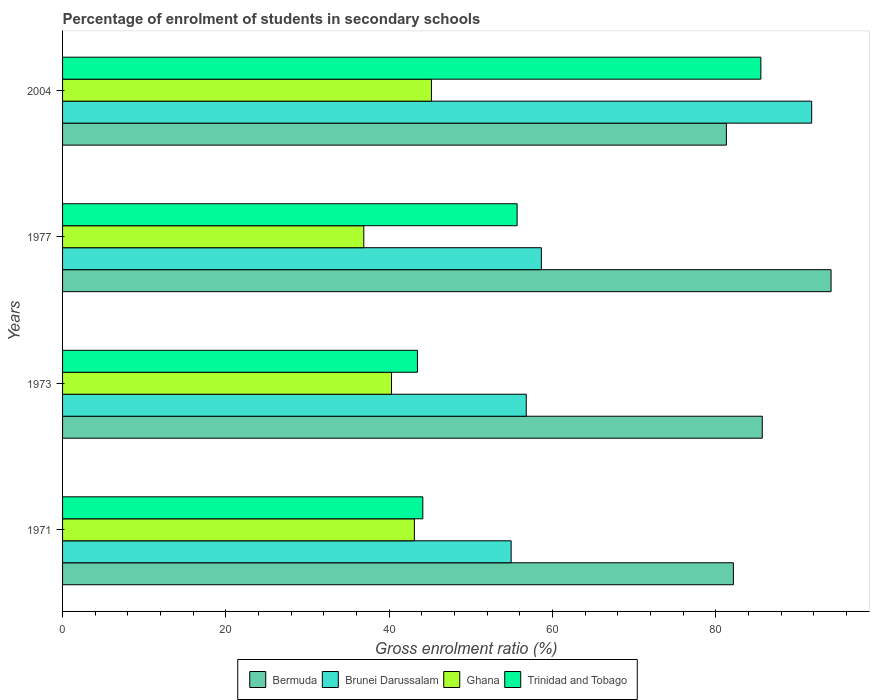What is the label of the 3rd group of bars from the top?
Your answer should be very brief. 1973. In how many cases, is the number of bars for a given year not equal to the number of legend labels?
Your response must be concise. 0. What is the percentage of students enrolled in secondary schools in Ghana in 2004?
Keep it short and to the point. 45.17. Across all years, what is the maximum percentage of students enrolled in secondary schools in Brunei Darussalam?
Your answer should be very brief. 91.74. Across all years, what is the minimum percentage of students enrolled in secondary schools in Brunei Darussalam?
Keep it short and to the point. 54.94. What is the total percentage of students enrolled in secondary schools in Brunei Darussalam in the graph?
Offer a terse response. 262.11. What is the difference between the percentage of students enrolled in secondary schools in Ghana in 1973 and that in 1977?
Keep it short and to the point. 3.39. What is the difference between the percentage of students enrolled in secondary schools in Trinidad and Tobago in 1971 and the percentage of students enrolled in secondary schools in Brunei Darussalam in 2004?
Give a very brief answer. -47.62. What is the average percentage of students enrolled in secondary schools in Bermuda per year?
Provide a succinct answer. 85.82. In the year 1977, what is the difference between the percentage of students enrolled in secondary schools in Trinidad and Tobago and percentage of students enrolled in secondary schools in Ghana?
Your answer should be very brief. 18.78. In how many years, is the percentage of students enrolled in secondary schools in Brunei Darussalam greater than 16 %?
Make the answer very short. 4. What is the ratio of the percentage of students enrolled in secondary schools in Brunei Darussalam in 1971 to that in 2004?
Give a very brief answer. 0.6. Is the difference between the percentage of students enrolled in secondary schools in Trinidad and Tobago in 1973 and 1977 greater than the difference between the percentage of students enrolled in secondary schools in Ghana in 1973 and 1977?
Offer a very short reply. No. What is the difference between the highest and the second highest percentage of students enrolled in secondary schools in Ghana?
Provide a short and direct response. 2.09. What is the difference between the highest and the lowest percentage of students enrolled in secondary schools in Bermuda?
Ensure brevity in your answer.  12.82. In how many years, is the percentage of students enrolled in secondary schools in Brunei Darussalam greater than the average percentage of students enrolled in secondary schools in Brunei Darussalam taken over all years?
Provide a short and direct response. 1. What does the 3rd bar from the top in 1977 represents?
Offer a terse response. Brunei Darussalam. Are all the bars in the graph horizontal?
Offer a very short reply. Yes. How many years are there in the graph?
Make the answer very short. 4. What is the difference between two consecutive major ticks on the X-axis?
Your answer should be compact. 20. Are the values on the major ticks of X-axis written in scientific E-notation?
Ensure brevity in your answer.  No. How many legend labels are there?
Offer a very short reply. 4. What is the title of the graph?
Keep it short and to the point. Percentage of enrolment of students in secondary schools. What is the Gross enrolment ratio (%) in Bermuda in 1971?
Provide a succinct answer. 82.16. What is the Gross enrolment ratio (%) of Brunei Darussalam in 1971?
Offer a terse response. 54.94. What is the Gross enrolment ratio (%) in Ghana in 1971?
Provide a succinct answer. 43.09. What is the Gross enrolment ratio (%) in Trinidad and Tobago in 1971?
Provide a short and direct response. 44.12. What is the Gross enrolment ratio (%) in Bermuda in 1973?
Offer a terse response. 85.69. What is the Gross enrolment ratio (%) of Brunei Darussalam in 1973?
Your answer should be compact. 56.79. What is the Gross enrolment ratio (%) in Ghana in 1973?
Offer a terse response. 40.28. What is the Gross enrolment ratio (%) in Trinidad and Tobago in 1973?
Make the answer very short. 43.46. What is the Gross enrolment ratio (%) in Bermuda in 1977?
Ensure brevity in your answer.  94.12. What is the Gross enrolment ratio (%) of Brunei Darussalam in 1977?
Keep it short and to the point. 58.64. What is the Gross enrolment ratio (%) of Ghana in 1977?
Offer a terse response. 36.89. What is the Gross enrolment ratio (%) in Trinidad and Tobago in 1977?
Provide a succinct answer. 55.67. What is the Gross enrolment ratio (%) in Bermuda in 2004?
Provide a succinct answer. 81.3. What is the Gross enrolment ratio (%) of Brunei Darussalam in 2004?
Make the answer very short. 91.74. What is the Gross enrolment ratio (%) in Ghana in 2004?
Provide a succinct answer. 45.17. What is the Gross enrolment ratio (%) of Trinidad and Tobago in 2004?
Offer a terse response. 85.52. Across all years, what is the maximum Gross enrolment ratio (%) of Bermuda?
Your answer should be compact. 94.12. Across all years, what is the maximum Gross enrolment ratio (%) of Brunei Darussalam?
Provide a short and direct response. 91.74. Across all years, what is the maximum Gross enrolment ratio (%) in Ghana?
Offer a very short reply. 45.17. Across all years, what is the maximum Gross enrolment ratio (%) in Trinidad and Tobago?
Provide a succinct answer. 85.52. Across all years, what is the minimum Gross enrolment ratio (%) in Bermuda?
Your response must be concise. 81.3. Across all years, what is the minimum Gross enrolment ratio (%) in Brunei Darussalam?
Offer a very short reply. 54.94. Across all years, what is the minimum Gross enrolment ratio (%) in Ghana?
Offer a terse response. 36.89. Across all years, what is the minimum Gross enrolment ratio (%) in Trinidad and Tobago?
Provide a short and direct response. 43.46. What is the total Gross enrolment ratio (%) of Bermuda in the graph?
Your response must be concise. 343.26. What is the total Gross enrolment ratio (%) in Brunei Darussalam in the graph?
Offer a terse response. 262.11. What is the total Gross enrolment ratio (%) of Ghana in the graph?
Provide a succinct answer. 165.43. What is the total Gross enrolment ratio (%) of Trinidad and Tobago in the graph?
Provide a short and direct response. 228.77. What is the difference between the Gross enrolment ratio (%) of Bermuda in 1971 and that in 1973?
Your answer should be very brief. -3.54. What is the difference between the Gross enrolment ratio (%) in Brunei Darussalam in 1971 and that in 1973?
Your answer should be very brief. -1.85. What is the difference between the Gross enrolment ratio (%) of Ghana in 1971 and that in 1973?
Your response must be concise. 2.8. What is the difference between the Gross enrolment ratio (%) of Trinidad and Tobago in 1971 and that in 1973?
Offer a very short reply. 0.66. What is the difference between the Gross enrolment ratio (%) in Bermuda in 1971 and that in 1977?
Give a very brief answer. -11.96. What is the difference between the Gross enrolment ratio (%) in Brunei Darussalam in 1971 and that in 1977?
Your answer should be compact. -3.7. What is the difference between the Gross enrolment ratio (%) of Ghana in 1971 and that in 1977?
Keep it short and to the point. 6.19. What is the difference between the Gross enrolment ratio (%) of Trinidad and Tobago in 1971 and that in 1977?
Ensure brevity in your answer.  -11.55. What is the difference between the Gross enrolment ratio (%) in Bermuda in 1971 and that in 2004?
Give a very brief answer. 0.86. What is the difference between the Gross enrolment ratio (%) of Brunei Darussalam in 1971 and that in 2004?
Offer a very short reply. -36.81. What is the difference between the Gross enrolment ratio (%) of Ghana in 1971 and that in 2004?
Provide a short and direct response. -2.09. What is the difference between the Gross enrolment ratio (%) in Trinidad and Tobago in 1971 and that in 2004?
Give a very brief answer. -41.4. What is the difference between the Gross enrolment ratio (%) in Bermuda in 1973 and that in 1977?
Your answer should be very brief. -8.43. What is the difference between the Gross enrolment ratio (%) of Brunei Darussalam in 1973 and that in 1977?
Offer a terse response. -1.85. What is the difference between the Gross enrolment ratio (%) in Ghana in 1973 and that in 1977?
Ensure brevity in your answer.  3.39. What is the difference between the Gross enrolment ratio (%) of Trinidad and Tobago in 1973 and that in 1977?
Offer a terse response. -12.21. What is the difference between the Gross enrolment ratio (%) of Bermuda in 1973 and that in 2004?
Ensure brevity in your answer.  4.4. What is the difference between the Gross enrolment ratio (%) of Brunei Darussalam in 1973 and that in 2004?
Keep it short and to the point. -34.96. What is the difference between the Gross enrolment ratio (%) of Ghana in 1973 and that in 2004?
Offer a terse response. -4.89. What is the difference between the Gross enrolment ratio (%) of Trinidad and Tobago in 1973 and that in 2004?
Your response must be concise. -42.06. What is the difference between the Gross enrolment ratio (%) in Bermuda in 1977 and that in 2004?
Offer a terse response. 12.82. What is the difference between the Gross enrolment ratio (%) of Brunei Darussalam in 1977 and that in 2004?
Make the answer very short. -33.1. What is the difference between the Gross enrolment ratio (%) in Ghana in 1977 and that in 2004?
Ensure brevity in your answer.  -8.28. What is the difference between the Gross enrolment ratio (%) in Trinidad and Tobago in 1977 and that in 2004?
Offer a very short reply. -29.85. What is the difference between the Gross enrolment ratio (%) in Bermuda in 1971 and the Gross enrolment ratio (%) in Brunei Darussalam in 1973?
Make the answer very short. 25.37. What is the difference between the Gross enrolment ratio (%) of Bermuda in 1971 and the Gross enrolment ratio (%) of Ghana in 1973?
Offer a terse response. 41.87. What is the difference between the Gross enrolment ratio (%) of Bermuda in 1971 and the Gross enrolment ratio (%) of Trinidad and Tobago in 1973?
Keep it short and to the point. 38.69. What is the difference between the Gross enrolment ratio (%) of Brunei Darussalam in 1971 and the Gross enrolment ratio (%) of Ghana in 1973?
Make the answer very short. 14.65. What is the difference between the Gross enrolment ratio (%) in Brunei Darussalam in 1971 and the Gross enrolment ratio (%) in Trinidad and Tobago in 1973?
Make the answer very short. 11.47. What is the difference between the Gross enrolment ratio (%) in Ghana in 1971 and the Gross enrolment ratio (%) in Trinidad and Tobago in 1973?
Provide a short and direct response. -0.38. What is the difference between the Gross enrolment ratio (%) in Bermuda in 1971 and the Gross enrolment ratio (%) in Brunei Darussalam in 1977?
Your answer should be very brief. 23.52. What is the difference between the Gross enrolment ratio (%) of Bermuda in 1971 and the Gross enrolment ratio (%) of Ghana in 1977?
Your answer should be compact. 45.26. What is the difference between the Gross enrolment ratio (%) of Bermuda in 1971 and the Gross enrolment ratio (%) of Trinidad and Tobago in 1977?
Ensure brevity in your answer.  26.49. What is the difference between the Gross enrolment ratio (%) of Brunei Darussalam in 1971 and the Gross enrolment ratio (%) of Ghana in 1977?
Provide a succinct answer. 18.04. What is the difference between the Gross enrolment ratio (%) in Brunei Darussalam in 1971 and the Gross enrolment ratio (%) in Trinidad and Tobago in 1977?
Make the answer very short. -0.73. What is the difference between the Gross enrolment ratio (%) in Ghana in 1971 and the Gross enrolment ratio (%) in Trinidad and Tobago in 1977?
Offer a very short reply. -12.58. What is the difference between the Gross enrolment ratio (%) of Bermuda in 1971 and the Gross enrolment ratio (%) of Brunei Darussalam in 2004?
Your answer should be very brief. -9.59. What is the difference between the Gross enrolment ratio (%) in Bermuda in 1971 and the Gross enrolment ratio (%) in Ghana in 2004?
Provide a short and direct response. 36.98. What is the difference between the Gross enrolment ratio (%) of Bermuda in 1971 and the Gross enrolment ratio (%) of Trinidad and Tobago in 2004?
Ensure brevity in your answer.  -3.37. What is the difference between the Gross enrolment ratio (%) in Brunei Darussalam in 1971 and the Gross enrolment ratio (%) in Ghana in 2004?
Your response must be concise. 9.76. What is the difference between the Gross enrolment ratio (%) in Brunei Darussalam in 1971 and the Gross enrolment ratio (%) in Trinidad and Tobago in 2004?
Give a very brief answer. -30.59. What is the difference between the Gross enrolment ratio (%) of Ghana in 1971 and the Gross enrolment ratio (%) of Trinidad and Tobago in 2004?
Offer a very short reply. -42.44. What is the difference between the Gross enrolment ratio (%) in Bermuda in 1973 and the Gross enrolment ratio (%) in Brunei Darussalam in 1977?
Make the answer very short. 27.05. What is the difference between the Gross enrolment ratio (%) of Bermuda in 1973 and the Gross enrolment ratio (%) of Ghana in 1977?
Provide a short and direct response. 48.8. What is the difference between the Gross enrolment ratio (%) of Bermuda in 1973 and the Gross enrolment ratio (%) of Trinidad and Tobago in 1977?
Your answer should be very brief. 30.03. What is the difference between the Gross enrolment ratio (%) of Brunei Darussalam in 1973 and the Gross enrolment ratio (%) of Ghana in 1977?
Provide a succinct answer. 19.89. What is the difference between the Gross enrolment ratio (%) in Brunei Darussalam in 1973 and the Gross enrolment ratio (%) in Trinidad and Tobago in 1977?
Offer a very short reply. 1.12. What is the difference between the Gross enrolment ratio (%) of Ghana in 1973 and the Gross enrolment ratio (%) of Trinidad and Tobago in 1977?
Make the answer very short. -15.39. What is the difference between the Gross enrolment ratio (%) in Bermuda in 1973 and the Gross enrolment ratio (%) in Brunei Darussalam in 2004?
Your answer should be compact. -6.05. What is the difference between the Gross enrolment ratio (%) of Bermuda in 1973 and the Gross enrolment ratio (%) of Ghana in 2004?
Your answer should be compact. 40.52. What is the difference between the Gross enrolment ratio (%) of Bermuda in 1973 and the Gross enrolment ratio (%) of Trinidad and Tobago in 2004?
Keep it short and to the point. 0.17. What is the difference between the Gross enrolment ratio (%) in Brunei Darussalam in 1973 and the Gross enrolment ratio (%) in Ghana in 2004?
Your response must be concise. 11.61. What is the difference between the Gross enrolment ratio (%) in Brunei Darussalam in 1973 and the Gross enrolment ratio (%) in Trinidad and Tobago in 2004?
Make the answer very short. -28.74. What is the difference between the Gross enrolment ratio (%) of Ghana in 1973 and the Gross enrolment ratio (%) of Trinidad and Tobago in 2004?
Give a very brief answer. -45.24. What is the difference between the Gross enrolment ratio (%) of Bermuda in 1977 and the Gross enrolment ratio (%) of Brunei Darussalam in 2004?
Your response must be concise. 2.38. What is the difference between the Gross enrolment ratio (%) of Bermuda in 1977 and the Gross enrolment ratio (%) of Ghana in 2004?
Your answer should be compact. 48.94. What is the difference between the Gross enrolment ratio (%) in Bermuda in 1977 and the Gross enrolment ratio (%) in Trinidad and Tobago in 2004?
Make the answer very short. 8.6. What is the difference between the Gross enrolment ratio (%) of Brunei Darussalam in 1977 and the Gross enrolment ratio (%) of Ghana in 2004?
Your answer should be very brief. 13.47. What is the difference between the Gross enrolment ratio (%) in Brunei Darussalam in 1977 and the Gross enrolment ratio (%) in Trinidad and Tobago in 2004?
Make the answer very short. -26.88. What is the difference between the Gross enrolment ratio (%) in Ghana in 1977 and the Gross enrolment ratio (%) in Trinidad and Tobago in 2004?
Offer a terse response. -48.63. What is the average Gross enrolment ratio (%) in Bermuda per year?
Your answer should be compact. 85.82. What is the average Gross enrolment ratio (%) in Brunei Darussalam per year?
Offer a very short reply. 65.53. What is the average Gross enrolment ratio (%) of Ghana per year?
Your response must be concise. 41.36. What is the average Gross enrolment ratio (%) in Trinidad and Tobago per year?
Provide a succinct answer. 57.19. In the year 1971, what is the difference between the Gross enrolment ratio (%) of Bermuda and Gross enrolment ratio (%) of Brunei Darussalam?
Offer a very short reply. 27.22. In the year 1971, what is the difference between the Gross enrolment ratio (%) in Bermuda and Gross enrolment ratio (%) in Ghana?
Offer a very short reply. 39.07. In the year 1971, what is the difference between the Gross enrolment ratio (%) in Bermuda and Gross enrolment ratio (%) in Trinidad and Tobago?
Provide a succinct answer. 38.04. In the year 1971, what is the difference between the Gross enrolment ratio (%) of Brunei Darussalam and Gross enrolment ratio (%) of Ghana?
Provide a short and direct response. 11.85. In the year 1971, what is the difference between the Gross enrolment ratio (%) in Brunei Darussalam and Gross enrolment ratio (%) in Trinidad and Tobago?
Provide a succinct answer. 10.82. In the year 1971, what is the difference between the Gross enrolment ratio (%) of Ghana and Gross enrolment ratio (%) of Trinidad and Tobago?
Offer a very short reply. -1.03. In the year 1973, what is the difference between the Gross enrolment ratio (%) in Bermuda and Gross enrolment ratio (%) in Brunei Darussalam?
Ensure brevity in your answer.  28.91. In the year 1973, what is the difference between the Gross enrolment ratio (%) in Bermuda and Gross enrolment ratio (%) in Ghana?
Provide a succinct answer. 45.41. In the year 1973, what is the difference between the Gross enrolment ratio (%) of Bermuda and Gross enrolment ratio (%) of Trinidad and Tobago?
Keep it short and to the point. 42.23. In the year 1973, what is the difference between the Gross enrolment ratio (%) of Brunei Darussalam and Gross enrolment ratio (%) of Ghana?
Make the answer very short. 16.5. In the year 1973, what is the difference between the Gross enrolment ratio (%) in Brunei Darussalam and Gross enrolment ratio (%) in Trinidad and Tobago?
Give a very brief answer. 13.32. In the year 1973, what is the difference between the Gross enrolment ratio (%) of Ghana and Gross enrolment ratio (%) of Trinidad and Tobago?
Provide a short and direct response. -3.18. In the year 1977, what is the difference between the Gross enrolment ratio (%) of Bermuda and Gross enrolment ratio (%) of Brunei Darussalam?
Provide a succinct answer. 35.48. In the year 1977, what is the difference between the Gross enrolment ratio (%) in Bermuda and Gross enrolment ratio (%) in Ghana?
Your response must be concise. 57.23. In the year 1977, what is the difference between the Gross enrolment ratio (%) of Bermuda and Gross enrolment ratio (%) of Trinidad and Tobago?
Your response must be concise. 38.45. In the year 1977, what is the difference between the Gross enrolment ratio (%) in Brunei Darussalam and Gross enrolment ratio (%) in Ghana?
Offer a very short reply. 21.75. In the year 1977, what is the difference between the Gross enrolment ratio (%) in Brunei Darussalam and Gross enrolment ratio (%) in Trinidad and Tobago?
Offer a very short reply. 2.97. In the year 1977, what is the difference between the Gross enrolment ratio (%) in Ghana and Gross enrolment ratio (%) in Trinidad and Tobago?
Ensure brevity in your answer.  -18.78. In the year 2004, what is the difference between the Gross enrolment ratio (%) of Bermuda and Gross enrolment ratio (%) of Brunei Darussalam?
Keep it short and to the point. -10.45. In the year 2004, what is the difference between the Gross enrolment ratio (%) of Bermuda and Gross enrolment ratio (%) of Ghana?
Your answer should be very brief. 36.12. In the year 2004, what is the difference between the Gross enrolment ratio (%) in Bermuda and Gross enrolment ratio (%) in Trinidad and Tobago?
Make the answer very short. -4.23. In the year 2004, what is the difference between the Gross enrolment ratio (%) in Brunei Darussalam and Gross enrolment ratio (%) in Ghana?
Provide a short and direct response. 46.57. In the year 2004, what is the difference between the Gross enrolment ratio (%) in Brunei Darussalam and Gross enrolment ratio (%) in Trinidad and Tobago?
Give a very brief answer. 6.22. In the year 2004, what is the difference between the Gross enrolment ratio (%) in Ghana and Gross enrolment ratio (%) in Trinidad and Tobago?
Offer a terse response. -40.35. What is the ratio of the Gross enrolment ratio (%) of Bermuda in 1971 to that in 1973?
Offer a very short reply. 0.96. What is the ratio of the Gross enrolment ratio (%) in Brunei Darussalam in 1971 to that in 1973?
Ensure brevity in your answer.  0.97. What is the ratio of the Gross enrolment ratio (%) of Ghana in 1971 to that in 1973?
Offer a terse response. 1.07. What is the ratio of the Gross enrolment ratio (%) in Trinidad and Tobago in 1971 to that in 1973?
Your response must be concise. 1.02. What is the ratio of the Gross enrolment ratio (%) of Bermuda in 1971 to that in 1977?
Offer a terse response. 0.87. What is the ratio of the Gross enrolment ratio (%) in Brunei Darussalam in 1971 to that in 1977?
Give a very brief answer. 0.94. What is the ratio of the Gross enrolment ratio (%) of Ghana in 1971 to that in 1977?
Your answer should be compact. 1.17. What is the ratio of the Gross enrolment ratio (%) of Trinidad and Tobago in 1971 to that in 1977?
Offer a terse response. 0.79. What is the ratio of the Gross enrolment ratio (%) in Bermuda in 1971 to that in 2004?
Give a very brief answer. 1.01. What is the ratio of the Gross enrolment ratio (%) in Brunei Darussalam in 1971 to that in 2004?
Offer a very short reply. 0.6. What is the ratio of the Gross enrolment ratio (%) of Ghana in 1971 to that in 2004?
Make the answer very short. 0.95. What is the ratio of the Gross enrolment ratio (%) in Trinidad and Tobago in 1971 to that in 2004?
Make the answer very short. 0.52. What is the ratio of the Gross enrolment ratio (%) in Bermuda in 1973 to that in 1977?
Provide a short and direct response. 0.91. What is the ratio of the Gross enrolment ratio (%) of Brunei Darussalam in 1973 to that in 1977?
Make the answer very short. 0.97. What is the ratio of the Gross enrolment ratio (%) of Ghana in 1973 to that in 1977?
Give a very brief answer. 1.09. What is the ratio of the Gross enrolment ratio (%) of Trinidad and Tobago in 1973 to that in 1977?
Ensure brevity in your answer.  0.78. What is the ratio of the Gross enrolment ratio (%) in Bermuda in 1973 to that in 2004?
Offer a very short reply. 1.05. What is the ratio of the Gross enrolment ratio (%) of Brunei Darussalam in 1973 to that in 2004?
Keep it short and to the point. 0.62. What is the ratio of the Gross enrolment ratio (%) in Ghana in 1973 to that in 2004?
Your answer should be compact. 0.89. What is the ratio of the Gross enrolment ratio (%) in Trinidad and Tobago in 1973 to that in 2004?
Ensure brevity in your answer.  0.51. What is the ratio of the Gross enrolment ratio (%) of Bermuda in 1977 to that in 2004?
Provide a short and direct response. 1.16. What is the ratio of the Gross enrolment ratio (%) in Brunei Darussalam in 1977 to that in 2004?
Ensure brevity in your answer.  0.64. What is the ratio of the Gross enrolment ratio (%) in Ghana in 1977 to that in 2004?
Provide a short and direct response. 0.82. What is the ratio of the Gross enrolment ratio (%) of Trinidad and Tobago in 1977 to that in 2004?
Your answer should be compact. 0.65. What is the difference between the highest and the second highest Gross enrolment ratio (%) of Bermuda?
Give a very brief answer. 8.43. What is the difference between the highest and the second highest Gross enrolment ratio (%) of Brunei Darussalam?
Provide a short and direct response. 33.1. What is the difference between the highest and the second highest Gross enrolment ratio (%) in Ghana?
Give a very brief answer. 2.09. What is the difference between the highest and the second highest Gross enrolment ratio (%) of Trinidad and Tobago?
Keep it short and to the point. 29.85. What is the difference between the highest and the lowest Gross enrolment ratio (%) of Bermuda?
Your response must be concise. 12.82. What is the difference between the highest and the lowest Gross enrolment ratio (%) in Brunei Darussalam?
Make the answer very short. 36.81. What is the difference between the highest and the lowest Gross enrolment ratio (%) of Ghana?
Provide a short and direct response. 8.28. What is the difference between the highest and the lowest Gross enrolment ratio (%) in Trinidad and Tobago?
Provide a short and direct response. 42.06. 